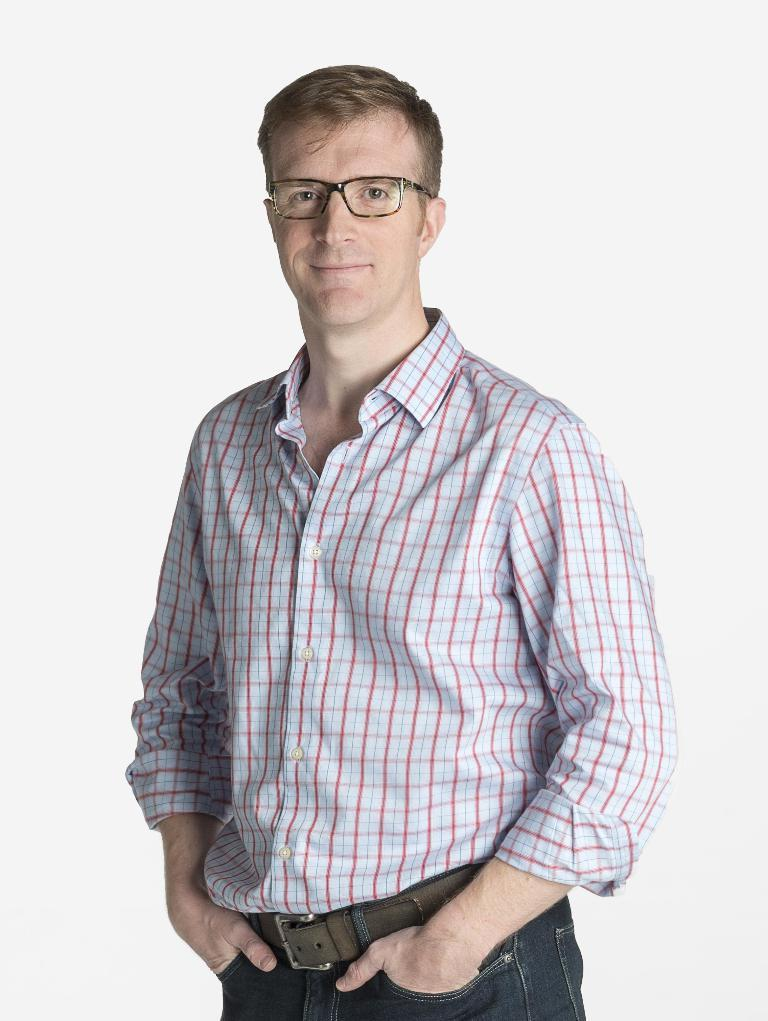What is the main subject of the image? There is a man in the image. Where is the man positioned in the image? The man is standing in the center of the image. What accessory is the man wearing? The man is wearing spectacles. What type of learning is taking place in the image? There is no indication of any learning or educational activity in the image; it simply features a man standing in the center wearing spectacles. 